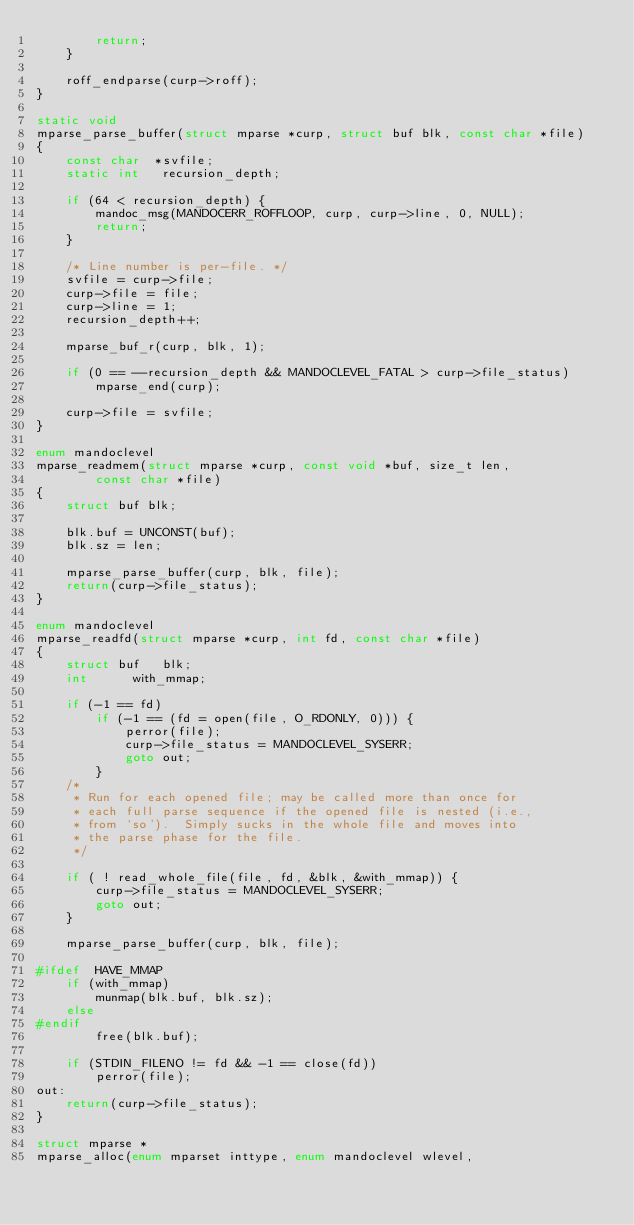Convert code to text. <code><loc_0><loc_0><loc_500><loc_500><_C_>		return;
	}

	roff_endparse(curp->roff);
}

static void
mparse_parse_buffer(struct mparse *curp, struct buf blk, const char *file)
{
	const char	*svfile;
	static int	 recursion_depth;

	if (64 < recursion_depth) {
		mandoc_msg(MANDOCERR_ROFFLOOP, curp, curp->line, 0, NULL);
		return;
	}

	/* Line number is per-file. */
	svfile = curp->file;
	curp->file = file;
	curp->line = 1;
	recursion_depth++;

	mparse_buf_r(curp, blk, 1);

	if (0 == --recursion_depth && MANDOCLEVEL_FATAL > curp->file_status)
		mparse_end(curp);

	curp->file = svfile;
}

enum mandoclevel
mparse_readmem(struct mparse *curp, const void *buf, size_t len,
		const char *file)
{
	struct buf blk;

	blk.buf = UNCONST(buf);
	blk.sz = len;

	mparse_parse_buffer(curp, blk, file);
	return(curp->file_status);
}

enum mandoclevel
mparse_readfd(struct mparse *curp, int fd, const char *file)
{
	struct buf	 blk;
	int		 with_mmap;

	if (-1 == fd)
		if (-1 == (fd = open(file, O_RDONLY, 0))) {
			perror(file);
			curp->file_status = MANDOCLEVEL_SYSERR;
			goto out;
		}
	/*
	 * Run for each opened file; may be called more than once for
	 * each full parse sequence if the opened file is nested (i.e.,
	 * from `so').  Simply sucks in the whole file and moves into
	 * the parse phase for the file.
	 */

	if ( ! read_whole_file(file, fd, &blk, &with_mmap)) {
		curp->file_status = MANDOCLEVEL_SYSERR;
		goto out;
	}

	mparse_parse_buffer(curp, blk, file);

#ifdef	HAVE_MMAP
	if (with_mmap)
		munmap(blk.buf, blk.sz);
	else
#endif
		free(blk.buf);

	if (STDIN_FILENO != fd && -1 == close(fd))
		perror(file);
out:
	return(curp->file_status);
}

struct mparse *
mparse_alloc(enum mparset inttype, enum mandoclevel wlevel,</code> 